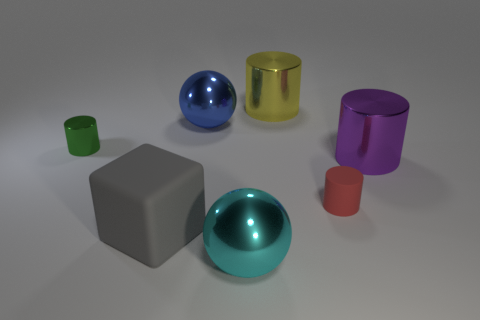Subtract all big yellow cylinders. How many cylinders are left? 3 Add 1 large gray cubes. How many objects exist? 8 Subtract all cubes. How many objects are left? 6 Subtract 1 balls. How many balls are left? 1 Subtract all red cylinders. How many cylinders are left? 3 Add 7 cyan objects. How many cyan objects are left? 8 Add 2 big blue rubber cylinders. How many big blue rubber cylinders exist? 2 Subtract 0 green spheres. How many objects are left? 7 Subtract all red spheres. Subtract all red cylinders. How many spheres are left? 2 Subtract all yellow spheres. How many brown cubes are left? 0 